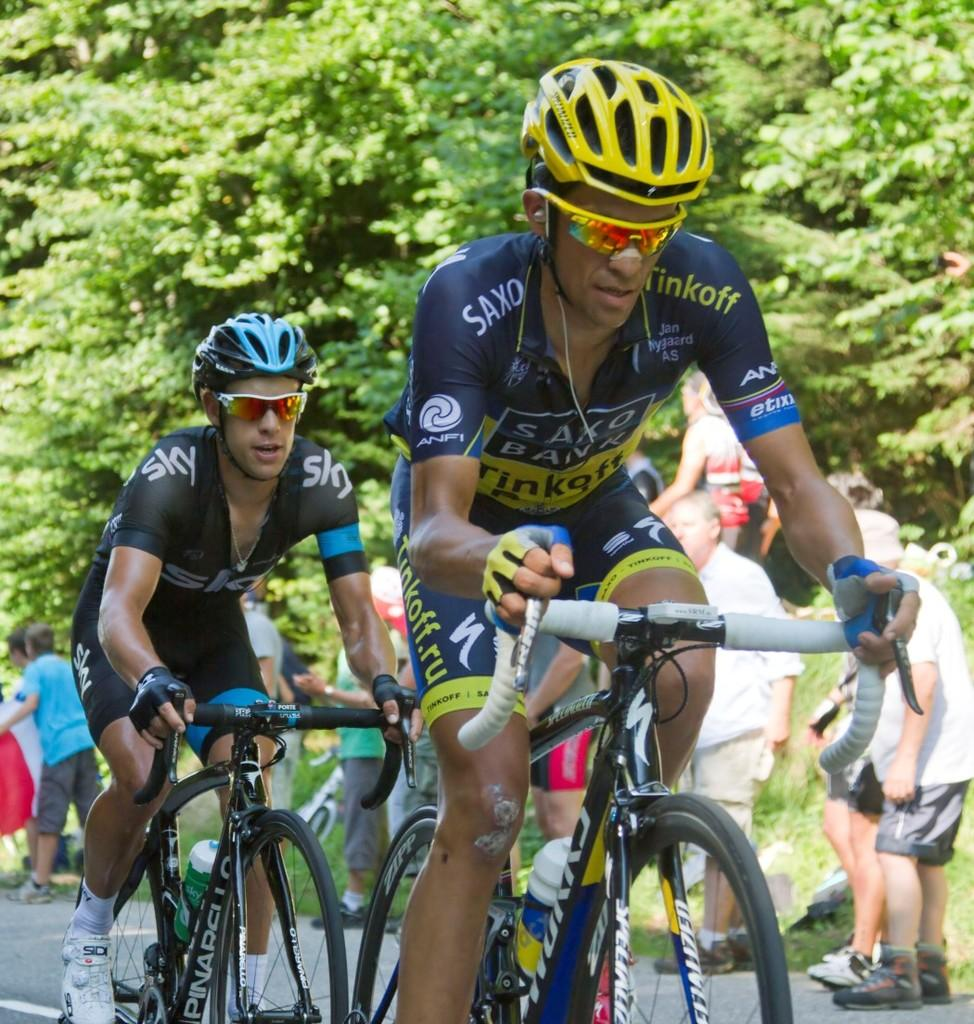What activity are the two persons in the image engaged in? The two persons in the image are riding bicycles. What safety equipment are the persons wearing? The persons are wearing helmets and goggles. What can be seen in the background of the image? There is a group of people standing in the background of the image, and trees are also visible. How does the growth of the trees affect the group of people in the image? The growth of the trees does not affect the group of people in the image, as they are standing in the background and not interacting with the trees. 